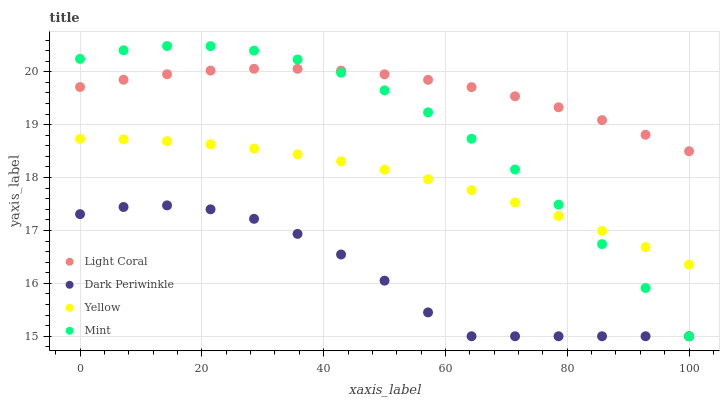Does Dark Periwinkle have the minimum area under the curve?
Answer yes or no. Yes. Does Light Coral have the maximum area under the curve?
Answer yes or no. Yes. Does Mint have the minimum area under the curve?
Answer yes or no. No. Does Mint have the maximum area under the curve?
Answer yes or no. No. Is Yellow the smoothest?
Answer yes or no. Yes. Is Dark Periwinkle the roughest?
Answer yes or no. Yes. Is Mint the smoothest?
Answer yes or no. No. Is Mint the roughest?
Answer yes or no. No. Does Mint have the lowest value?
Answer yes or no. Yes. Does Yellow have the lowest value?
Answer yes or no. No. Does Mint have the highest value?
Answer yes or no. Yes. Does Dark Periwinkle have the highest value?
Answer yes or no. No. Is Dark Periwinkle less than Light Coral?
Answer yes or no. Yes. Is Light Coral greater than Yellow?
Answer yes or no. Yes. Does Dark Periwinkle intersect Mint?
Answer yes or no. Yes. Is Dark Periwinkle less than Mint?
Answer yes or no. No. Is Dark Periwinkle greater than Mint?
Answer yes or no. No. Does Dark Periwinkle intersect Light Coral?
Answer yes or no. No. 